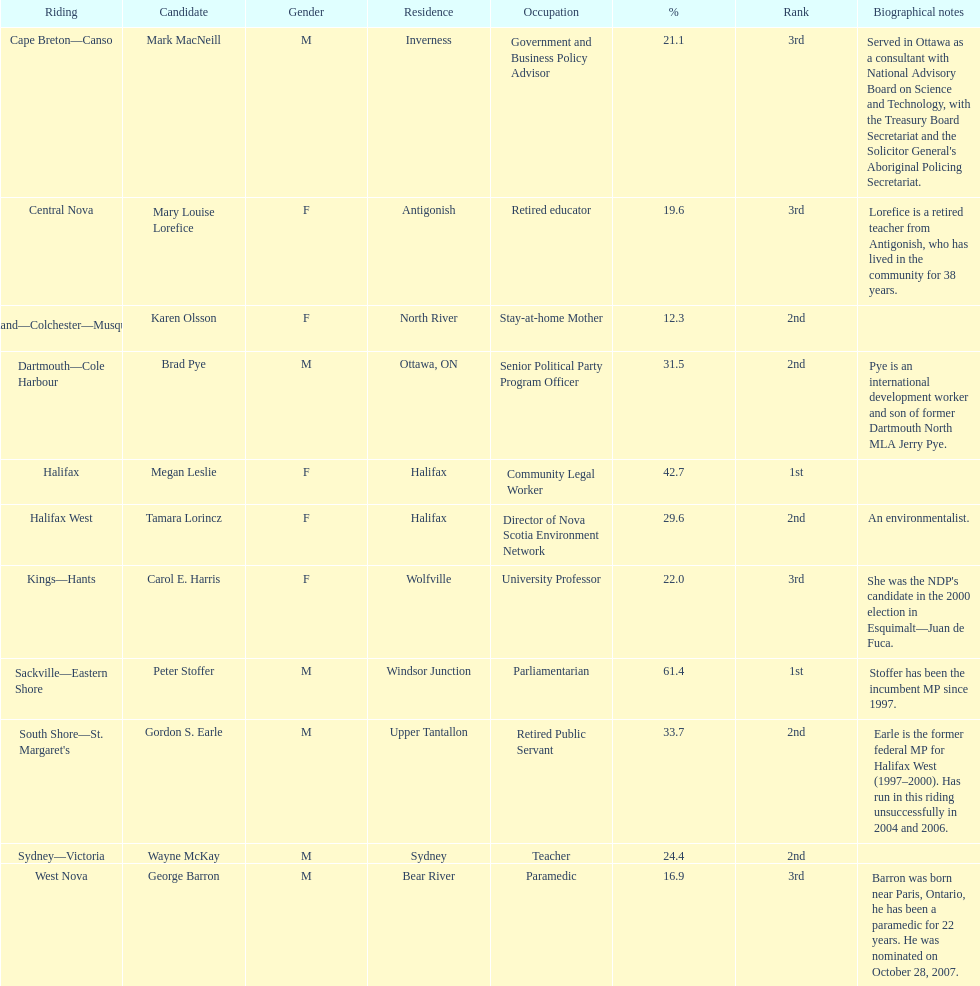Inform me of the overall amount of votes the female candidates received. 52,277. 